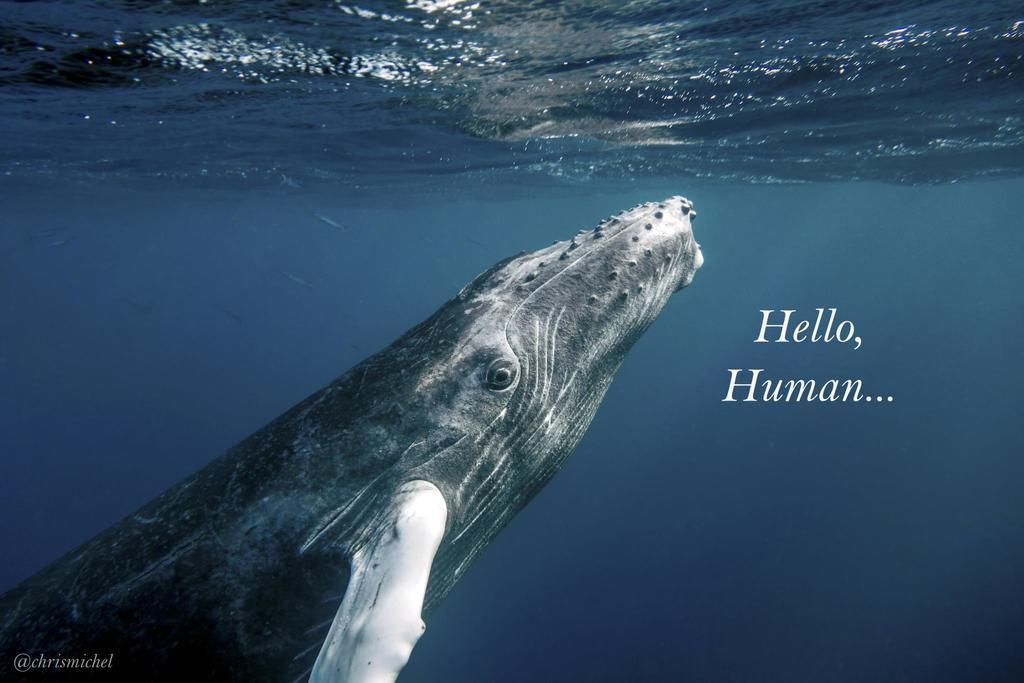What is featured on the poster in the image? The poster contains a picture of an animal and an image of water. What else can be found on the poster besides the images? There is text written on the poster. Where can you buy the jam that is mentioned on the poster? There is no mention of jam on the poster, so it cannot be purchased based on the information provided in the image. 